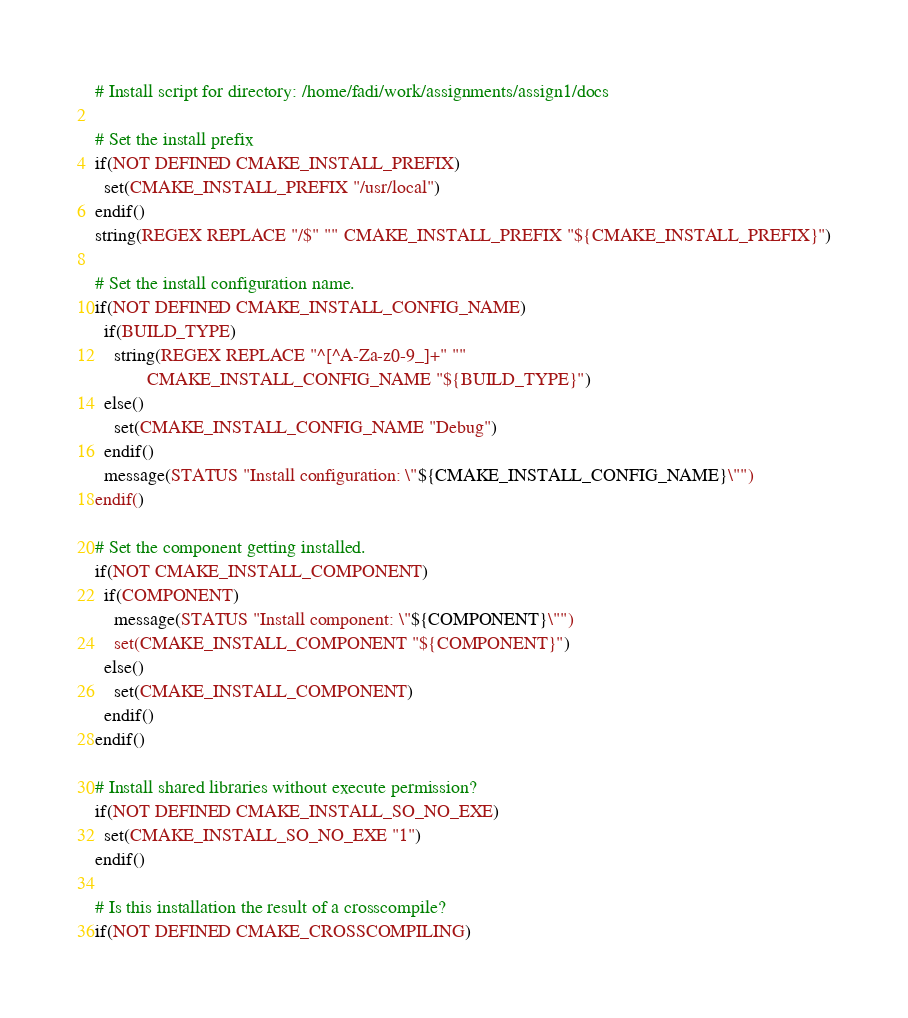<code> <loc_0><loc_0><loc_500><loc_500><_CMake_># Install script for directory: /home/fadi/work/assignments/assign1/docs

# Set the install prefix
if(NOT DEFINED CMAKE_INSTALL_PREFIX)
  set(CMAKE_INSTALL_PREFIX "/usr/local")
endif()
string(REGEX REPLACE "/$" "" CMAKE_INSTALL_PREFIX "${CMAKE_INSTALL_PREFIX}")

# Set the install configuration name.
if(NOT DEFINED CMAKE_INSTALL_CONFIG_NAME)
  if(BUILD_TYPE)
    string(REGEX REPLACE "^[^A-Za-z0-9_]+" ""
           CMAKE_INSTALL_CONFIG_NAME "${BUILD_TYPE}")
  else()
    set(CMAKE_INSTALL_CONFIG_NAME "Debug")
  endif()
  message(STATUS "Install configuration: \"${CMAKE_INSTALL_CONFIG_NAME}\"")
endif()

# Set the component getting installed.
if(NOT CMAKE_INSTALL_COMPONENT)
  if(COMPONENT)
    message(STATUS "Install component: \"${COMPONENT}\"")
    set(CMAKE_INSTALL_COMPONENT "${COMPONENT}")
  else()
    set(CMAKE_INSTALL_COMPONENT)
  endif()
endif()

# Install shared libraries without execute permission?
if(NOT DEFINED CMAKE_INSTALL_SO_NO_EXE)
  set(CMAKE_INSTALL_SO_NO_EXE "1")
endif()

# Is this installation the result of a crosscompile?
if(NOT DEFINED CMAKE_CROSSCOMPILING)</code> 